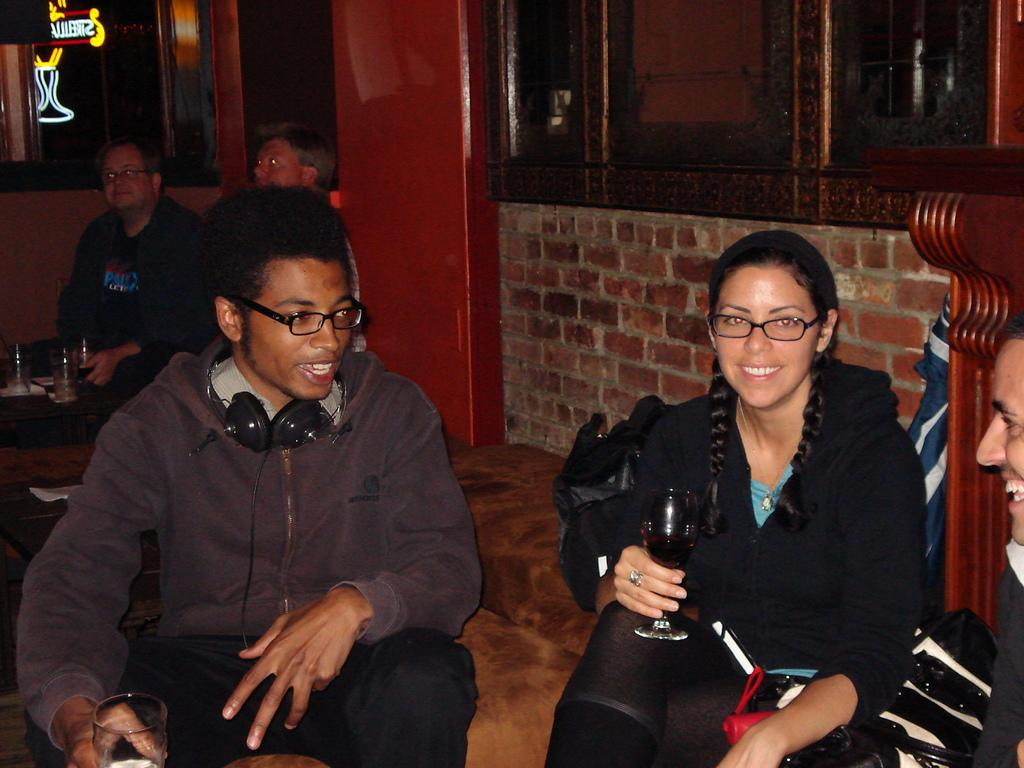What are the people in the image doing? The people in the image are sitting. What are the people holding in their hands? The people are holding glasses. What type of furniture can be seen in the image? There are tables and chairs in the image. What can be seen in the background of the image? There is a wall and windows visible in the background. What is located on the left side of the image? There is a board on the left side of the image. Can you see a bear interacting with the people in the image? No, there is no bear present in the image. What type of farming equipment is being used by the grandfather in the image? There is no grandfather or farming equipment present in the image. 